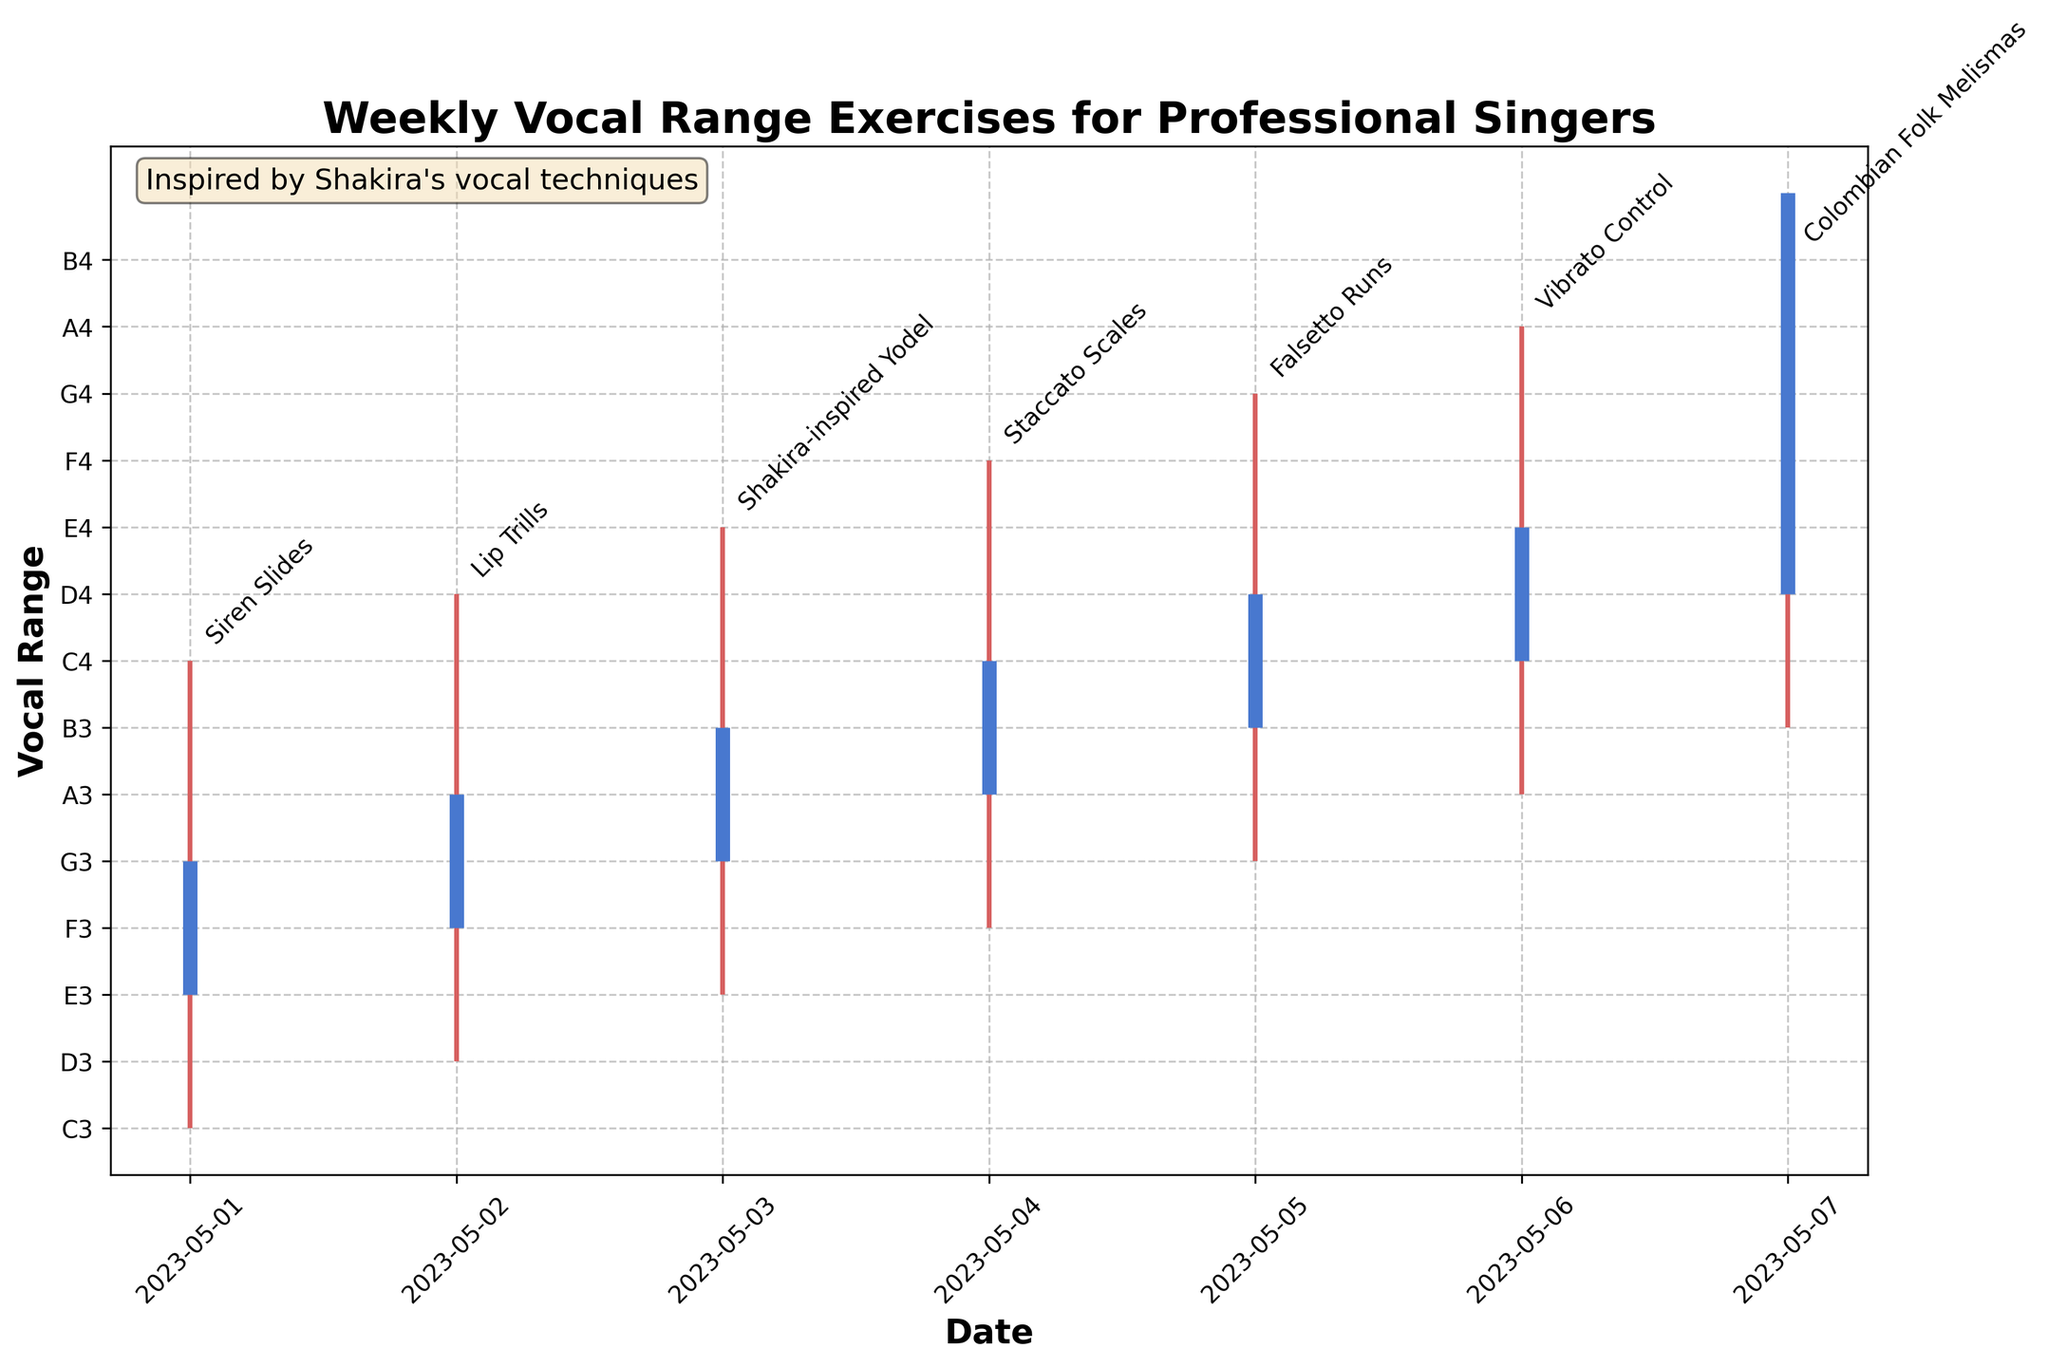What is the title of the figure? The title of the figure is located at the top and is clearly marked in the plot.
Answer: Weekly Vocal Range Exercises for Professional Singers What are the labels on the x-axis and y-axis? The x-axis label is "Date" and the y-axis label is "Vocal Range". These labels are located on the horizontal and vertical axes respectively.
Answer: Date, Vocal Range Which exercise has the highest note "E4"? By looking at the high notes of each exercise, "Shakira-inspired Yodel" on 2023-05-03 reaches E4.
Answer: Shakira-inspired Yodel How many exercises have the open and close notes the same? Observing the plot, the exercises where the blue lines (open and close notes) coincide are "Colombian Folk Melismas" on 2023-05-07.
Answer: 1 Which exercise has the widest range between its low and high notes? The vocal ranges can be calculated and the exercise "Vibrato Control" on 2023-05-06 has the widest range from A3 to A4.
Answer: Vibrato Control What is the average high note for the week? The high notes for each exercise are C4, D4, E4, F4, G4, A4, and B4. Converting them to their numerical order and calculating the average: (C4+D4+E4+F4+G4+A4+B4) / 7.
Answer: average(A4) Which day has the highest number of notes in the G4 range? Observing the plot, the highest note G4 appears on 2023-05-05 for "Falsetto Runs".
Answer: 2023-05-05 On which day does the exercise note not reach above C4? Looking at each daily exercise range, on 2023-05-01 (Siren Slides) and 2023-05-02 (Lip Trills) the highest note does not exceed C4.
Answer: 2023-05-01, 2023-05-02 What is the difference between the high notes of "Lip Trills" and "Siren Slides"? The high note for 'Lip Trills' is D4 and for 'Siren Slides' is C4. D4 is one note higher than C4.
Answer: 1 note 